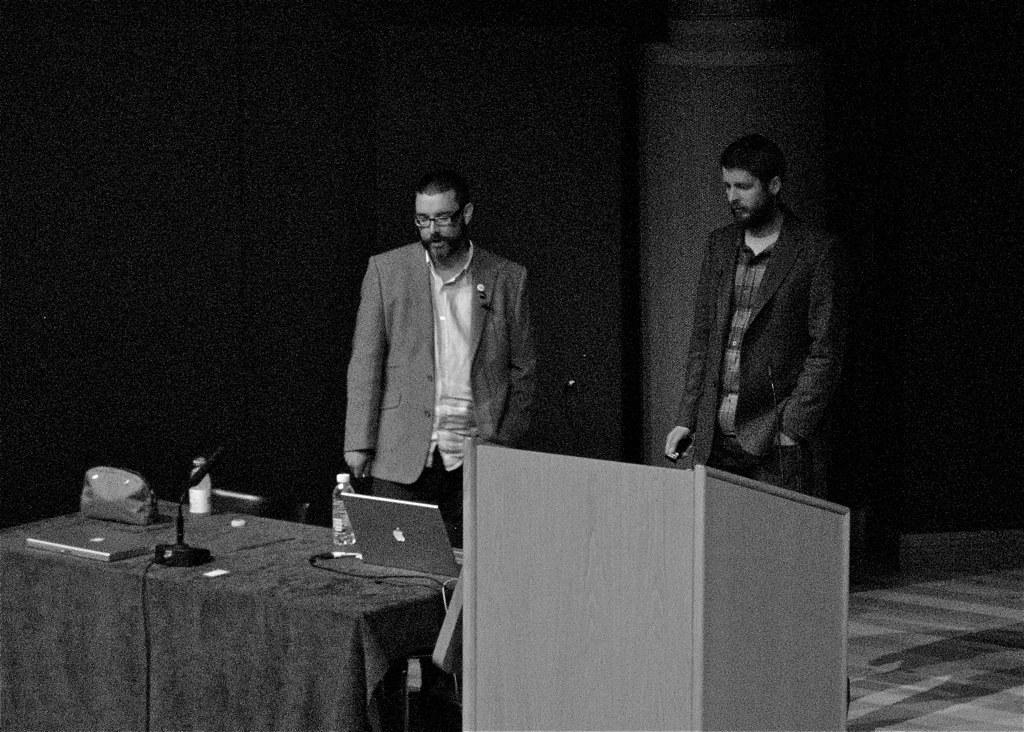How many men are in the image? There are two men in the image. What are the men doing in the image? The men are standing in the image. What is in front of the men? There is a table in front of the men. What is on the table? The table has laptops, a bottle, and a microphone on it. What is beside the table? There is a speech desk beside the table. What type of cobweb can be seen hanging from the ceiling in the image? There is no cobweb visible in the image. What smell is present in the room in the image? The image does not provide any information about smells in the room. 